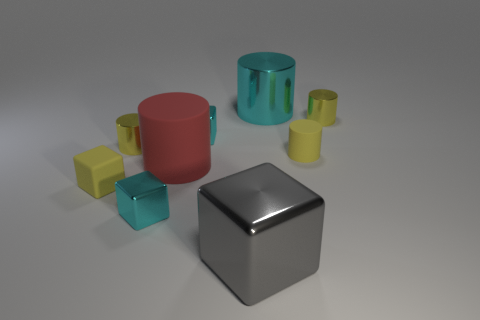Are there any yellow matte cylinders that have the same size as the gray object?
Provide a succinct answer. No. Is the number of large yellow shiny cubes less than the number of big gray blocks?
Offer a terse response. Yes. How many blocks are either small cyan things or gray things?
Keep it short and to the point. 3. How many big metallic cubes are the same color as the tiny matte cylinder?
Give a very brief answer. 0. There is a yellow object that is both behind the big red matte thing and to the left of the large cyan metal cylinder; what size is it?
Your answer should be very brief. Small. Is the number of gray shiny objects behind the big cyan shiny object less than the number of small brown metallic cylinders?
Your answer should be compact. No. Is the material of the big gray thing the same as the large cyan object?
Offer a terse response. Yes. What number of objects are either green rubber blocks or blocks?
Your answer should be very brief. 4. What number of small cylinders are made of the same material as the red object?
Make the answer very short. 1. There is a yellow rubber object that is the same shape as the large red rubber thing; what size is it?
Your answer should be compact. Small. 